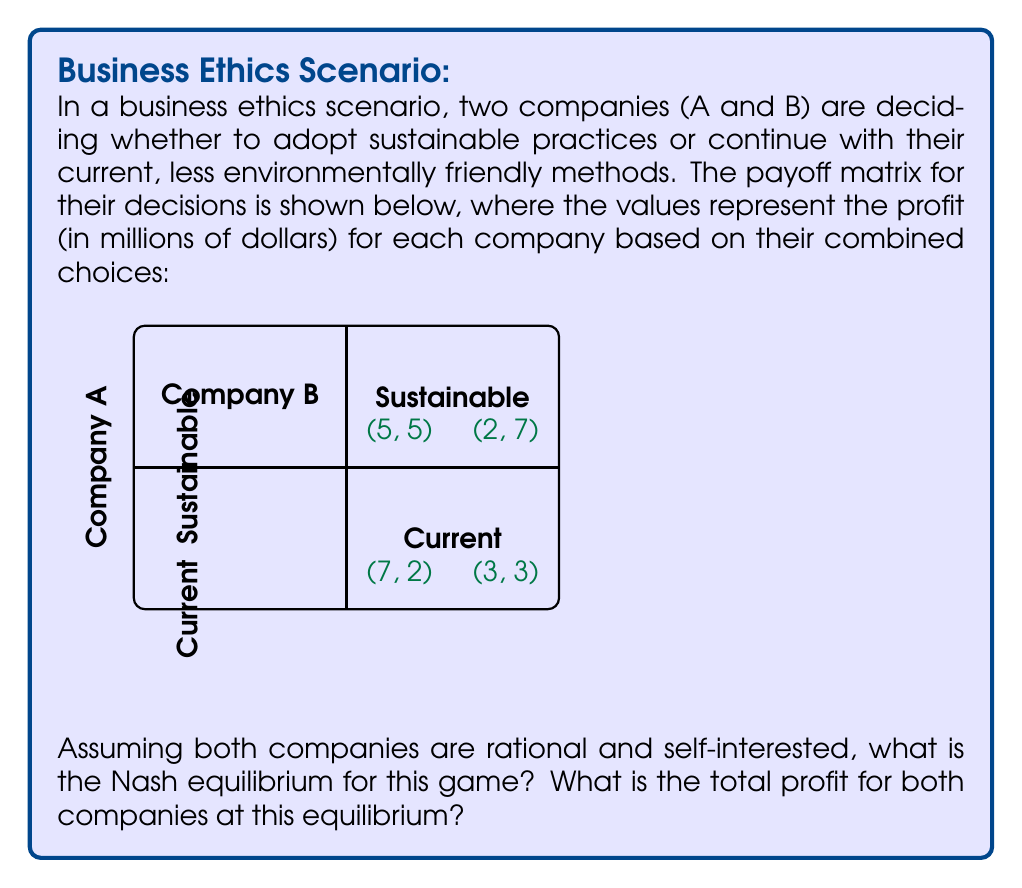Show me your answer to this math problem. To solve this problem, we need to follow these steps:

1) Identify the best responses for each company:

   For Company A:
   - If B chooses Sustainable, A's best response is Current (7 > 5)
   - If B chooses Current, A's best response is Current (3 > 2)

   For Company B:
   - If A chooses Sustainable, B's best response is Current (7 > 5)
   - If A chooses Current, B's best response is Current (3 > 2)

2) The Nash equilibrium is the strategy profile where each player is playing their best response to the other player's strategy. From our analysis, we can see that (Current, Current) is the Nash equilibrium, as neither player has an incentive to unilaterally deviate from this strategy.

3) At the Nash equilibrium (Current, Current), the payoff for each company is 3 million dollars.

4) The total profit at this equilibrium is the sum of both companies' profits:

   $$ \text{Total Profit} = 3 + 3 = 6 \text{ million dollars} $$

This result demonstrates a classic "prisoner's dilemma" scenario in business ethics, where individual rational choices lead to a suboptimal outcome for both parties. If both companies had chosen to adopt sustainable practices, they would have each earned 5 million dollars, for a total of 10 million dollars.
Answer: Nash equilibrium: (Current, Current); Total profit: $6 million 